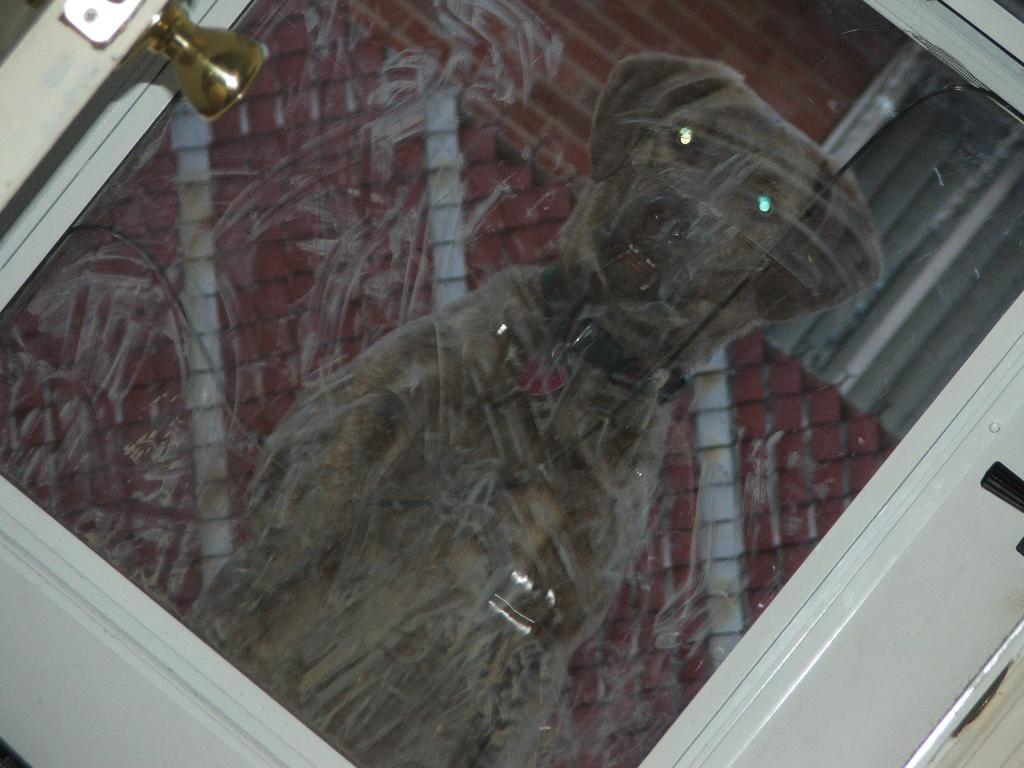What type of door is visible in the image? There is a door with a glass pane in the image. What can be seen on the glass pane of the door? There is a reflection of a dog on the glass pane. Are there any other reflections visible on the glass pane? Yes, there are reflections of other objects on the glass pane. Is there a lock visible on the door in the image? There is no mention of a lock in the provided facts, so we cannot determine if one is visible in the image. 